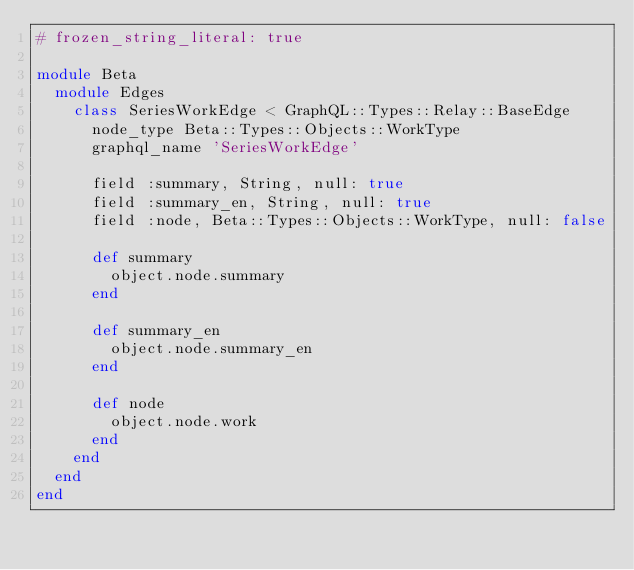Convert code to text. <code><loc_0><loc_0><loc_500><loc_500><_Ruby_># frozen_string_literal: true

module Beta
  module Edges
    class SeriesWorkEdge < GraphQL::Types::Relay::BaseEdge
      node_type Beta::Types::Objects::WorkType
      graphql_name 'SeriesWorkEdge'

      field :summary, String, null: true
      field :summary_en, String, null: true
      field :node, Beta::Types::Objects::WorkType, null: false

      def summary
        object.node.summary
      end

      def summary_en
        object.node.summary_en
      end

      def node
        object.node.work
      end
    end
  end
end
</code> 